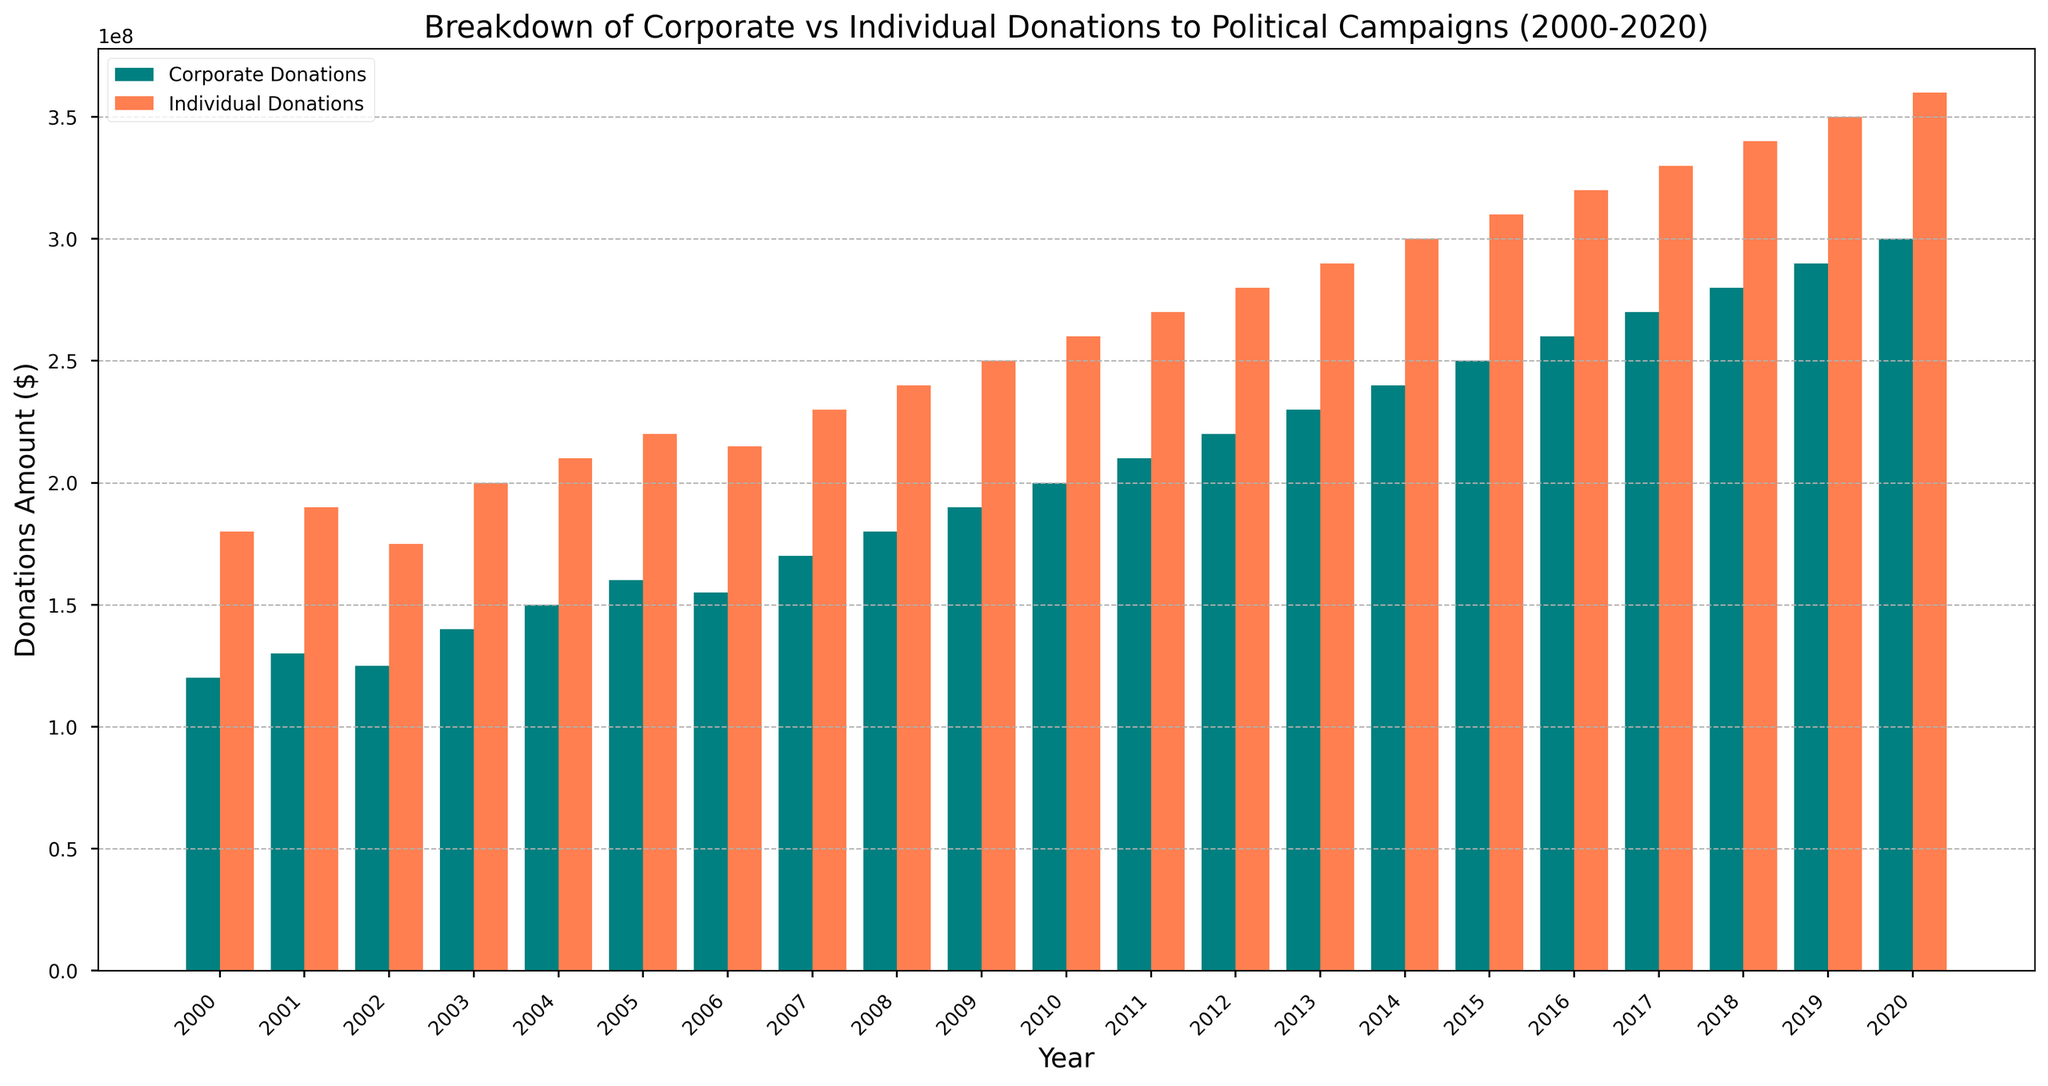Which year had the highest individual donations? By examining the bars labeled "Individual Donations," the tallest bar corresponds to 2020.
Answer: 2020 What's the total amount of corporate and individual donations in 2010? Sum the height values of both bars for the year 2010: Corporate Donations ($200M) + Individual Donations ($260M) = $460M.
Answer: $460,000,000 In which year is the difference between corporate and individual donations the smallest? Calculate the difference for each year and identify the smallest one. The minimum difference is in 2006 ($215M - $155M = $60M).
Answer: 2006 Do corporate or individual donations show a steeper growth trend from 2000 to 2020? Visually examining the slopes, both donations increase, but individual donations have a consistently larger increase year-over-year.
Answer: Individual Donations Which color bar represents corporate donations? The legend shows that "Corporate Donations" are represented by teal-colored bars.
Answer: Teal What's the average corporate donation amount between 2000 and 2005? Sum corporate donations from 2000 to 2005 ($120M + $130M + $125M + $140M + $150M + $160M) = $825M, then divide by 6 years. Average = $825M / 6 = $137.5M.
Answer: $137,500,000 By how much did individual donations increase from 2008 to 2020? Subtract the 2008 value from the 2020 value for Individual Donations: $360M - $240M = $120M increase.
Answer: $120,000,000 Which year marks the first time corporate donations reached or exceeded $200M? Check the "Corporate Donations" bars and identify the first year the bar reaches or exceeds $200M, which is 2010.
Answer: 2010 Are there any years where corporate donations decreased from the previous year? Checking the height of "Corporate Donations" bars year-over-year, the only decrease occurs from 2006 ($160M) to 2007 ($155M).
Answer: Yes, in 2007 What is the ratio of individual to corporate donations in 2015? Calculate the ratio by dividing individual donations by corporate donations for 2015: $310M / $250M = 1.24.
Answer: 1.24 